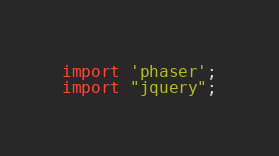Convert code to text. <code><loc_0><loc_0><loc_500><loc_500><_JavaScript_>import 'phaser';
import "jquery";
</code> 